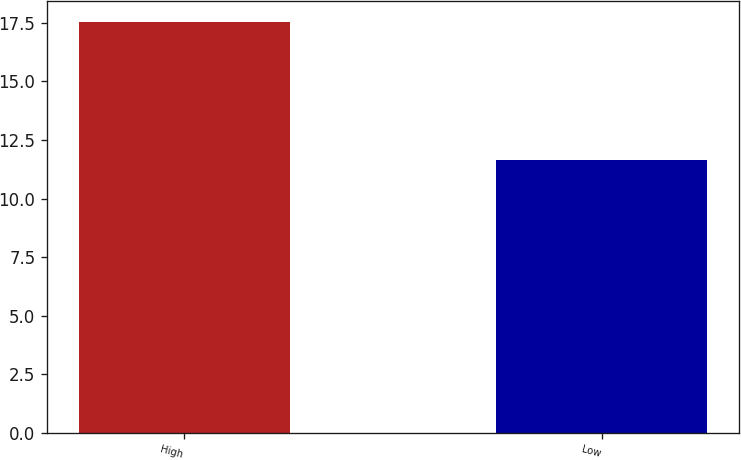<chart> <loc_0><loc_0><loc_500><loc_500><bar_chart><fcel>High<fcel>Low<nl><fcel>17.55<fcel>11.64<nl></chart> 